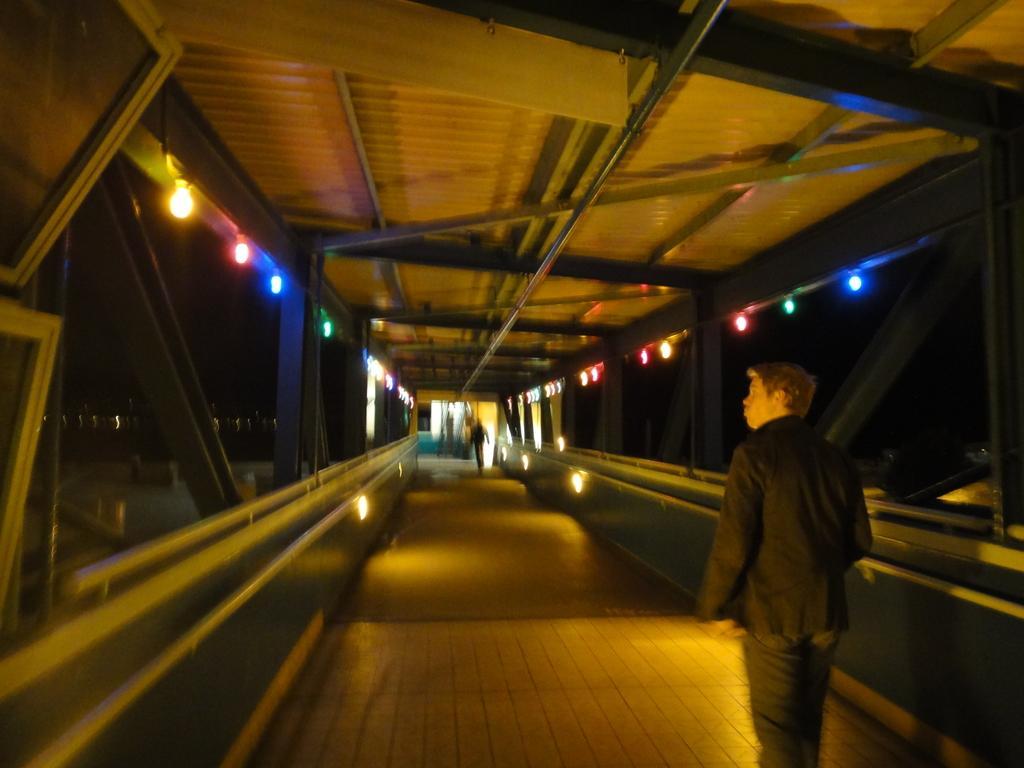Please provide a concise description of this image. In this image there is a bridge and we can see people. There are lights. At the top we can see a roof. 